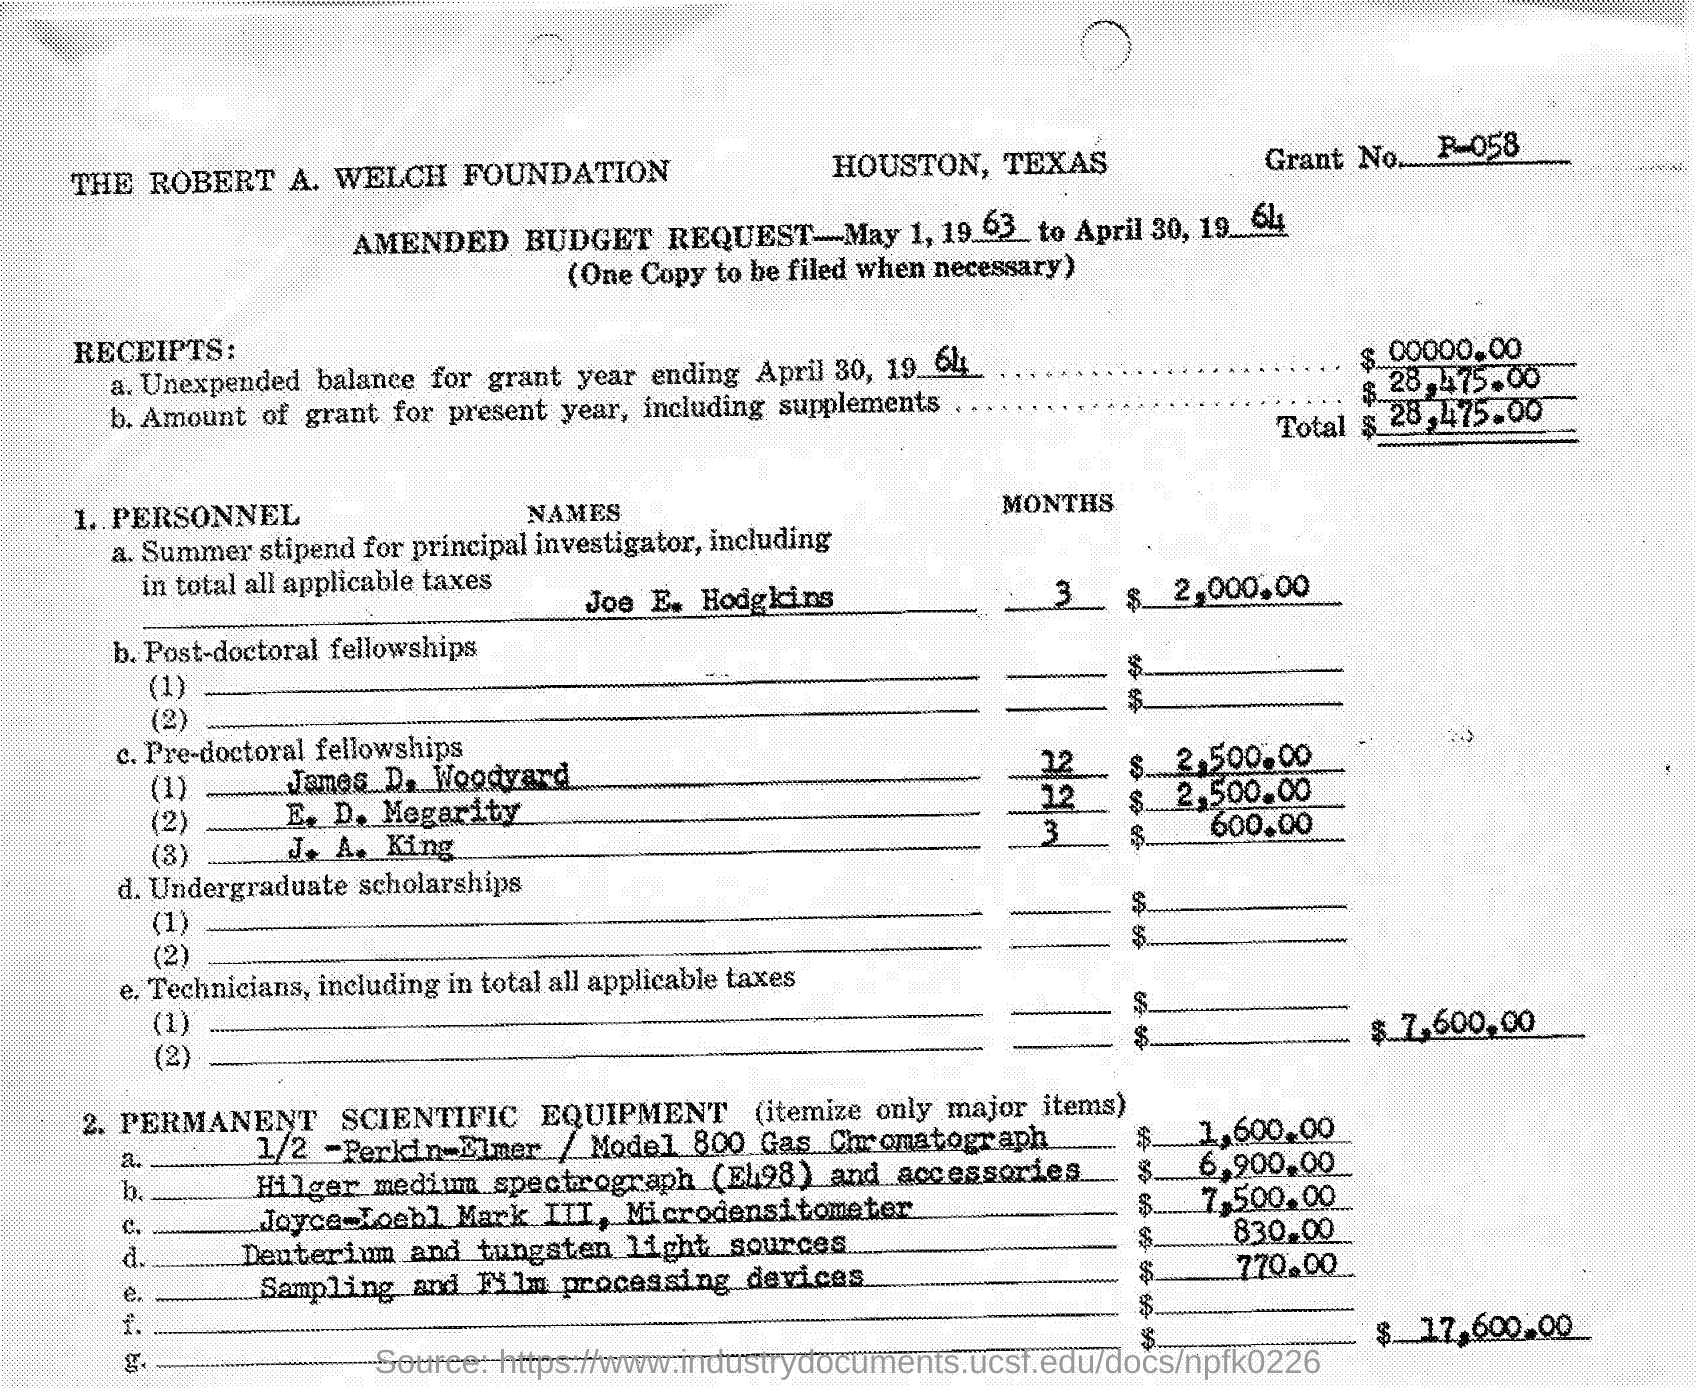Point out several critical features in this image. The cost of the Sampling and Film processing device is $770.00. The amended budget request, from May 1, 1963 to April 30, 1964, is a time period of duration. The total amount of dollars granted for the present year, including supplements, is $28,475.00. J. A. King presumed his pre-doctor fellowship for 3 months. The amount paid as a summer stipend for Joe E. Hodgkins is $2,000.00. 